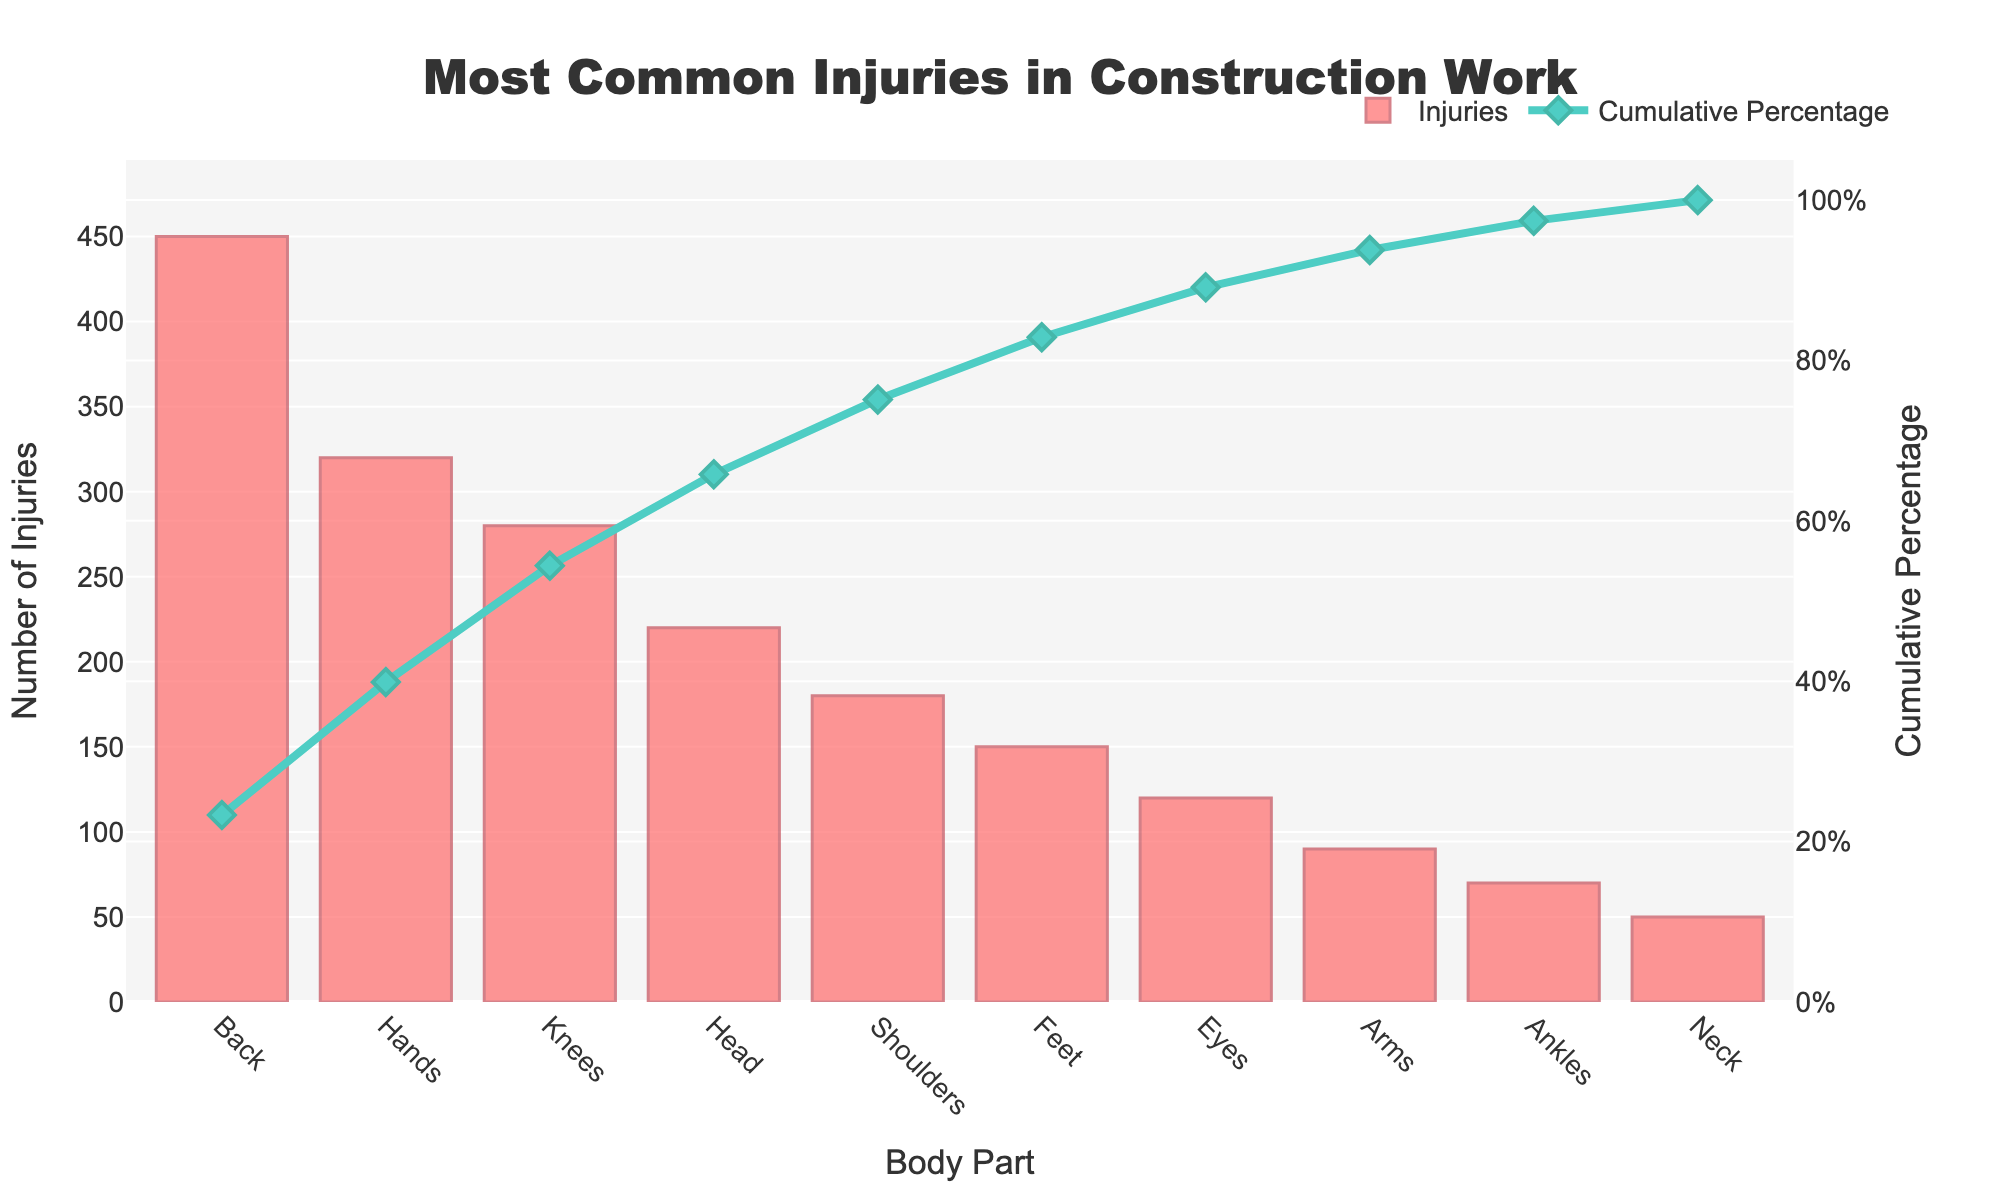What is the title of the Pareto chart? The title of the chart is prominently displayed at the top. It summarizes what the chart represents.
Answer: Most Common Injuries in Construction Work Which body part has the highest number of injuries? The bar corresponding to the body part with the largest height indicates the highest number of injuries.
Answer: Back What is the cumulative percentage for injuries affecting the knees? Find the position of "Knees" on the x-axis and read the corresponding value on the secondary y-axis (right side) from the line chart.
Answer: 70% How many injuries affect the shoulders? The bar height for "Shoulders" on the chart indicates the number of injuries.
Answer: 180 Which body part has fewer injuries, ankles or neck? Compare the heights of the bars for "Ankles" and "Neck" to see which one is shorter, indicating fewer injuries.
Answer: Neck What is the cumulative percentage after considering the top three most injured body parts? Sum the cumulative percentages of the top three ranked body parts on the chart.
Answer: 67% By how much do injuries to the hands exceed those to the feet? Calculate the difference in the heights of the bars representing "Hands" and "Feet."
Answer: 170 What is the difference in cumulative percentage between shoulders and feet? Find the cumulative percentages for both "Shoulders" and "Feet" from the secondary y-axis and subtract the latter from the former.
Answer: 76% - 58% = 18% Which body part reaches the 50% cumulative percentage mark? Look at the secondary y-axis (right side) for the point at which the cumulative percentage line crosses 50%, then identify the corresponding body part on the x-axis.
Answer: Knees What percentage of total injuries are accounted for by injuries to the back, hands, and knees combined? Add the number of injuries for "Back," "Hands," and "Knees," and then divide by the total injuries, multiplying by 100 to convert to a percentage.
Answer: 1050 / 1930 * 100 ≈ 54.4% 